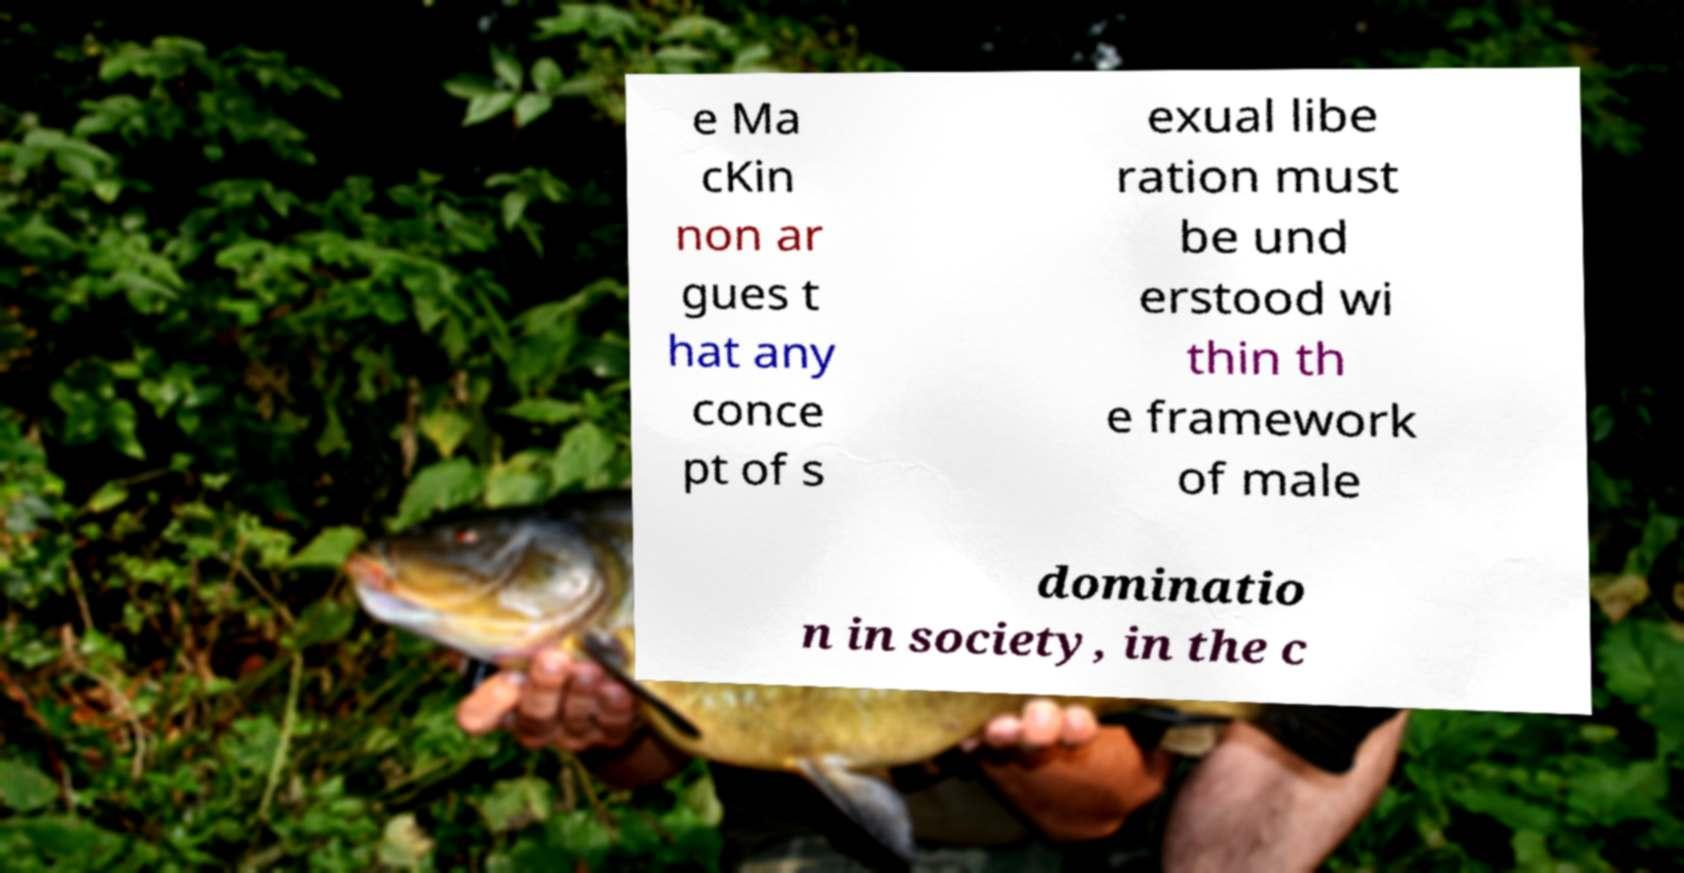Could you assist in decoding the text presented in this image and type it out clearly? e Ma cKin non ar gues t hat any conce pt of s exual libe ration must be und erstood wi thin th e framework of male dominatio n in society, in the c 